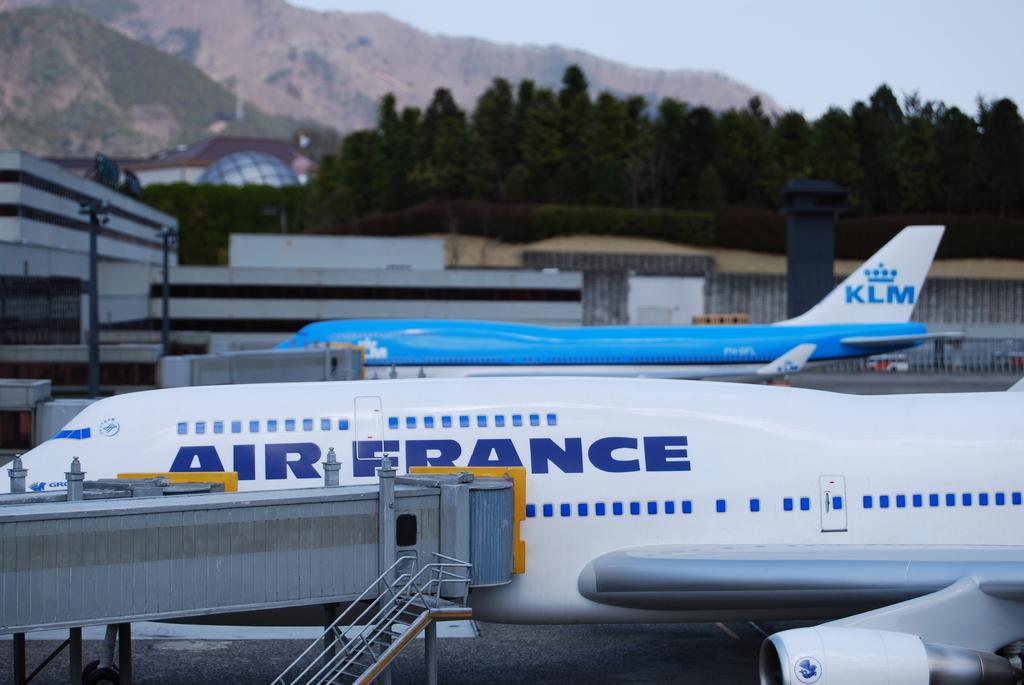What country is this airplane from?
Offer a terse response. France. What is the airline of the plane in the back?
Your response must be concise. Klm. 